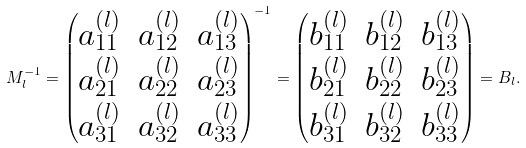<formula> <loc_0><loc_0><loc_500><loc_500>M _ { l } ^ { - 1 } = \begin{pmatrix} a _ { 1 1 } ^ { ( l ) } & a _ { 1 2 } ^ { ( l ) } & a _ { 1 3 } ^ { ( l ) } \\ a _ { 2 1 } ^ { ( l ) } & a _ { 2 2 } ^ { ( l ) } & a _ { 2 3 } ^ { ( l ) } \\ a _ { 3 1 } ^ { ( l ) } & a _ { 3 2 } ^ { ( l ) } & a _ { 3 3 } ^ { ( l ) } \end{pmatrix} ^ { - 1 } = \begin{pmatrix} b _ { 1 1 } ^ { ( l ) } & b _ { 1 2 } ^ { ( l ) } & b _ { 1 3 } ^ { ( l ) } \\ b _ { 2 1 } ^ { ( l ) } & b _ { 2 2 } ^ { ( l ) } & b _ { 2 3 } ^ { ( l ) } \\ b _ { 3 1 } ^ { ( l ) } & b _ { 3 2 } ^ { ( l ) } & b _ { 3 3 } ^ { ( l ) } \end{pmatrix} = B _ { l } .</formula> 